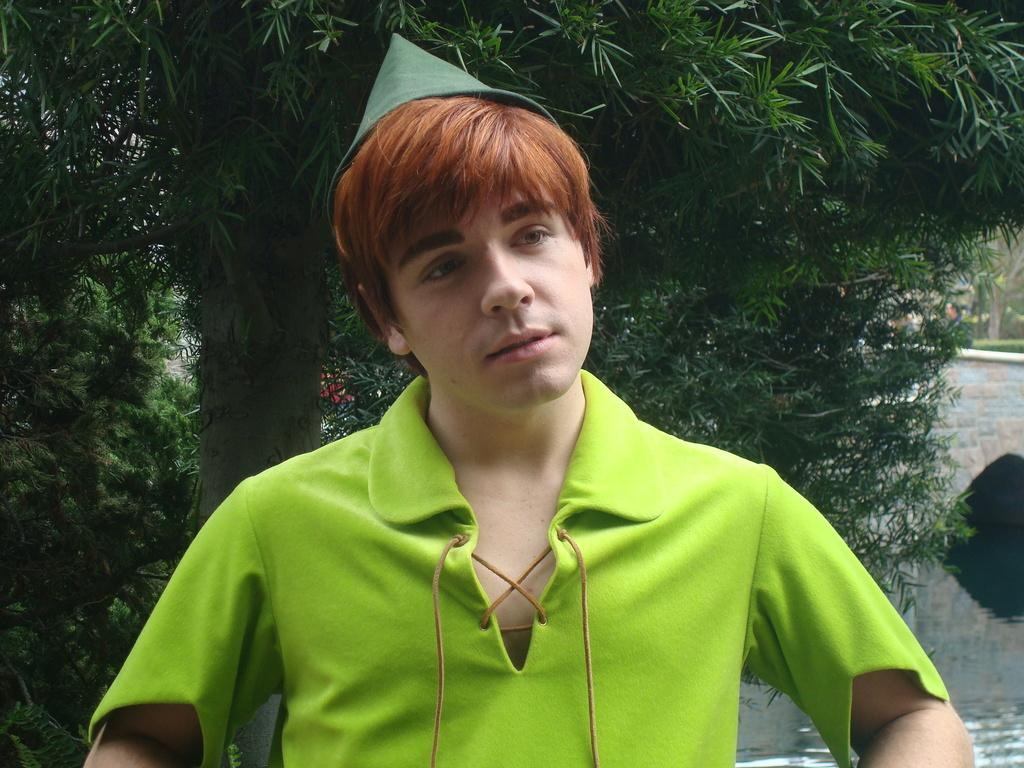What is the main subject in the foreground of the picture? There is a person in the foreground of the picture. What is the person wearing? The person is wearing a green dress. What can be seen in the background of the image? There are trees, water, and a bridge visible in the background of the image. What historical event is being commemorated by the person in the green dress? There is no indication of any historical event being commemorated in the image. The person is simply standing in the foreground wearing a green dress. 